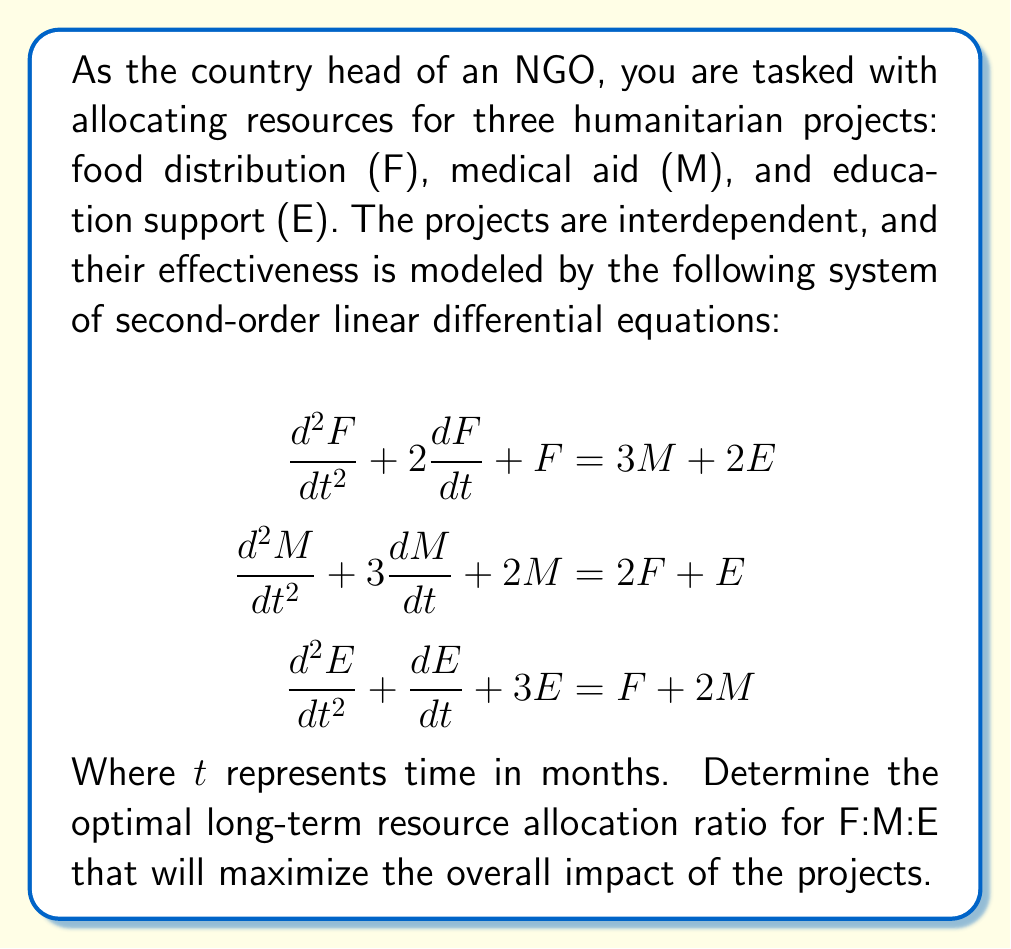Could you help me with this problem? To find the optimal long-term resource allocation, we need to analyze the steady-state solution of the system. In the long term, the rates of change will approach zero, so we can set all derivatives to zero:

$$\begin{aligned}
F &= 3M + 2E \\
2M &= 2F + E \\
3E &= F + 2M
\end{aligned}$$

Now we have a system of linear equations. To solve this system, we can use substitution or elimination methods. Let's use substitution:

1) From the second equation:
   $M = F + \frac{1}{2}E$

2) Substitute this into the first equation:
   $F = 3(F + \frac{1}{2}E) + 2E$
   $F = 3F + \frac{3}{2}E + 2E$
   $-2F = \frac{7}{2}E$
   $F = -\frac{7}{4}E$

3) Now substitute both expressions into the third equation:
   $3E = (-\frac{7}{4}E) + 2((-\frac{7}{4}E) + \frac{1}{2}E)$
   $3E = -\frac{7}{4}E - \frac{7}{2}E + E$
   $3E = -\frac{11}{4}E$
   $\frac{23}{4}E = 0$

4) This equation is only true if $E = 0$. If $E = 0$, then from step 2, we can conclude that $F = 0$.

5) If $F = 0$ and $E = 0$, then from the original second equation:
   $2M = 0$, so $M = 0$

This trivial solution (0:0:0) is not helpful for resource allocation. However, it indicates that any non-zero solution will be a scalar multiple of a single ratio. We can find this ratio by setting one variable to 1 and solving for the others.

Let's set $E = 1$:

6) From step 2: $F = -\frac{7}{4}$
7) From step 1: $M = -\frac{7}{4} + \frac{1}{2} = -\frac{5}{4}$

Therefore, the optimal long-term resource allocation ratio is:

$F : M : E = -\frac{7}{4} : -\frac{5}{4} : 1$

To express this in positive terms, we can multiply all terms by -4:

$F : M : E = 7 : 5 : 4$
Answer: The optimal long-term resource allocation ratio for Food distribution : Medical aid : Education support is 7 : 5 : 4. 